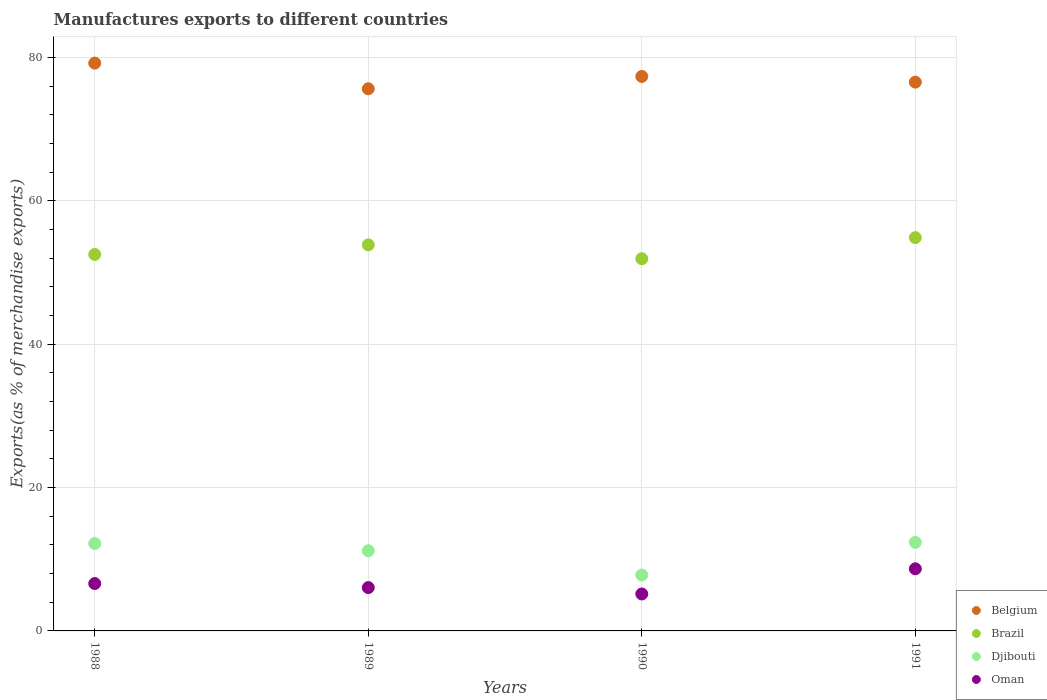How many different coloured dotlines are there?
Give a very brief answer. 4. What is the percentage of exports to different countries in Brazil in 1990?
Provide a succinct answer. 51.92. Across all years, what is the maximum percentage of exports to different countries in Belgium?
Your response must be concise. 79.2. Across all years, what is the minimum percentage of exports to different countries in Djibouti?
Provide a short and direct response. 7.79. In which year was the percentage of exports to different countries in Oman minimum?
Give a very brief answer. 1990. What is the total percentage of exports to different countries in Oman in the graph?
Provide a short and direct response. 26.47. What is the difference between the percentage of exports to different countries in Oman in 1989 and that in 1991?
Offer a very short reply. -2.62. What is the difference between the percentage of exports to different countries in Djibouti in 1991 and the percentage of exports to different countries in Belgium in 1989?
Give a very brief answer. -63.28. What is the average percentage of exports to different countries in Oman per year?
Your response must be concise. 6.62. In the year 1988, what is the difference between the percentage of exports to different countries in Belgium and percentage of exports to different countries in Brazil?
Your answer should be compact. 26.69. What is the ratio of the percentage of exports to different countries in Djibouti in 1990 to that in 1991?
Your answer should be very brief. 0.63. What is the difference between the highest and the second highest percentage of exports to different countries in Brazil?
Your answer should be very brief. 1.01. What is the difference between the highest and the lowest percentage of exports to different countries in Djibouti?
Provide a short and direct response. 4.55. In how many years, is the percentage of exports to different countries in Brazil greater than the average percentage of exports to different countries in Brazil taken over all years?
Ensure brevity in your answer.  2. Is it the case that in every year, the sum of the percentage of exports to different countries in Belgium and percentage of exports to different countries in Djibouti  is greater than the sum of percentage of exports to different countries in Oman and percentage of exports to different countries in Brazil?
Make the answer very short. No. Is it the case that in every year, the sum of the percentage of exports to different countries in Belgium and percentage of exports to different countries in Djibouti  is greater than the percentage of exports to different countries in Brazil?
Your answer should be compact. Yes. Does the percentage of exports to different countries in Belgium monotonically increase over the years?
Offer a very short reply. No. How many dotlines are there?
Your response must be concise. 4. Does the graph contain any zero values?
Ensure brevity in your answer.  No. Does the graph contain grids?
Give a very brief answer. Yes. Where does the legend appear in the graph?
Offer a terse response. Bottom right. What is the title of the graph?
Offer a terse response. Manufactures exports to different countries. Does "Indonesia" appear as one of the legend labels in the graph?
Give a very brief answer. No. What is the label or title of the Y-axis?
Offer a terse response. Exports(as % of merchandise exports). What is the Exports(as % of merchandise exports) in Belgium in 1988?
Provide a succinct answer. 79.2. What is the Exports(as % of merchandise exports) in Brazil in 1988?
Provide a short and direct response. 52.51. What is the Exports(as % of merchandise exports) of Djibouti in 1988?
Your response must be concise. 12.19. What is the Exports(as % of merchandise exports) in Oman in 1988?
Make the answer very short. 6.61. What is the Exports(as % of merchandise exports) of Belgium in 1989?
Your response must be concise. 75.62. What is the Exports(as % of merchandise exports) in Brazil in 1989?
Keep it short and to the point. 53.85. What is the Exports(as % of merchandise exports) of Djibouti in 1989?
Offer a very short reply. 11.19. What is the Exports(as % of merchandise exports) of Oman in 1989?
Ensure brevity in your answer.  6.04. What is the Exports(as % of merchandise exports) of Belgium in 1990?
Give a very brief answer. 77.35. What is the Exports(as % of merchandise exports) of Brazil in 1990?
Provide a short and direct response. 51.92. What is the Exports(as % of merchandise exports) in Djibouti in 1990?
Your answer should be very brief. 7.79. What is the Exports(as % of merchandise exports) of Oman in 1990?
Your answer should be very brief. 5.16. What is the Exports(as % of merchandise exports) of Belgium in 1991?
Your response must be concise. 76.55. What is the Exports(as % of merchandise exports) in Brazil in 1991?
Offer a terse response. 54.86. What is the Exports(as % of merchandise exports) of Djibouti in 1991?
Your answer should be compact. 12.35. What is the Exports(as % of merchandise exports) in Oman in 1991?
Your answer should be very brief. 8.67. Across all years, what is the maximum Exports(as % of merchandise exports) of Belgium?
Keep it short and to the point. 79.2. Across all years, what is the maximum Exports(as % of merchandise exports) of Brazil?
Give a very brief answer. 54.86. Across all years, what is the maximum Exports(as % of merchandise exports) in Djibouti?
Offer a very short reply. 12.35. Across all years, what is the maximum Exports(as % of merchandise exports) of Oman?
Provide a succinct answer. 8.67. Across all years, what is the minimum Exports(as % of merchandise exports) of Belgium?
Keep it short and to the point. 75.62. Across all years, what is the minimum Exports(as % of merchandise exports) of Brazil?
Make the answer very short. 51.92. Across all years, what is the minimum Exports(as % of merchandise exports) of Djibouti?
Your answer should be very brief. 7.79. Across all years, what is the minimum Exports(as % of merchandise exports) of Oman?
Provide a succinct answer. 5.16. What is the total Exports(as % of merchandise exports) of Belgium in the graph?
Ensure brevity in your answer.  308.72. What is the total Exports(as % of merchandise exports) in Brazil in the graph?
Provide a succinct answer. 213.14. What is the total Exports(as % of merchandise exports) of Djibouti in the graph?
Give a very brief answer. 43.52. What is the total Exports(as % of merchandise exports) of Oman in the graph?
Provide a short and direct response. 26.48. What is the difference between the Exports(as % of merchandise exports) in Belgium in 1988 and that in 1989?
Make the answer very short. 3.58. What is the difference between the Exports(as % of merchandise exports) in Brazil in 1988 and that in 1989?
Provide a succinct answer. -1.34. What is the difference between the Exports(as % of merchandise exports) in Oman in 1988 and that in 1989?
Your answer should be compact. 0.56. What is the difference between the Exports(as % of merchandise exports) of Belgium in 1988 and that in 1990?
Your answer should be compact. 1.86. What is the difference between the Exports(as % of merchandise exports) in Brazil in 1988 and that in 1990?
Offer a terse response. 0.6. What is the difference between the Exports(as % of merchandise exports) of Djibouti in 1988 and that in 1990?
Your response must be concise. 4.4. What is the difference between the Exports(as % of merchandise exports) of Oman in 1988 and that in 1990?
Offer a terse response. 1.45. What is the difference between the Exports(as % of merchandise exports) in Belgium in 1988 and that in 1991?
Make the answer very short. 2.65. What is the difference between the Exports(as % of merchandise exports) of Brazil in 1988 and that in 1991?
Provide a succinct answer. -2.35. What is the difference between the Exports(as % of merchandise exports) of Djibouti in 1988 and that in 1991?
Offer a very short reply. -0.16. What is the difference between the Exports(as % of merchandise exports) of Oman in 1988 and that in 1991?
Your answer should be very brief. -2.06. What is the difference between the Exports(as % of merchandise exports) in Belgium in 1989 and that in 1990?
Your response must be concise. -1.72. What is the difference between the Exports(as % of merchandise exports) of Brazil in 1989 and that in 1990?
Give a very brief answer. 1.93. What is the difference between the Exports(as % of merchandise exports) of Djibouti in 1989 and that in 1990?
Ensure brevity in your answer.  3.39. What is the difference between the Exports(as % of merchandise exports) of Oman in 1989 and that in 1990?
Give a very brief answer. 0.89. What is the difference between the Exports(as % of merchandise exports) of Belgium in 1989 and that in 1991?
Provide a succinct answer. -0.93. What is the difference between the Exports(as % of merchandise exports) of Brazil in 1989 and that in 1991?
Provide a succinct answer. -1.01. What is the difference between the Exports(as % of merchandise exports) in Djibouti in 1989 and that in 1991?
Provide a short and direct response. -1.16. What is the difference between the Exports(as % of merchandise exports) of Oman in 1989 and that in 1991?
Keep it short and to the point. -2.62. What is the difference between the Exports(as % of merchandise exports) in Belgium in 1990 and that in 1991?
Ensure brevity in your answer.  0.79. What is the difference between the Exports(as % of merchandise exports) of Brazil in 1990 and that in 1991?
Keep it short and to the point. -2.95. What is the difference between the Exports(as % of merchandise exports) of Djibouti in 1990 and that in 1991?
Keep it short and to the point. -4.55. What is the difference between the Exports(as % of merchandise exports) in Oman in 1990 and that in 1991?
Give a very brief answer. -3.51. What is the difference between the Exports(as % of merchandise exports) of Belgium in 1988 and the Exports(as % of merchandise exports) of Brazil in 1989?
Your response must be concise. 25.35. What is the difference between the Exports(as % of merchandise exports) of Belgium in 1988 and the Exports(as % of merchandise exports) of Djibouti in 1989?
Keep it short and to the point. 68.02. What is the difference between the Exports(as % of merchandise exports) in Belgium in 1988 and the Exports(as % of merchandise exports) in Oman in 1989?
Ensure brevity in your answer.  73.16. What is the difference between the Exports(as % of merchandise exports) of Brazil in 1988 and the Exports(as % of merchandise exports) of Djibouti in 1989?
Your response must be concise. 41.33. What is the difference between the Exports(as % of merchandise exports) of Brazil in 1988 and the Exports(as % of merchandise exports) of Oman in 1989?
Provide a succinct answer. 46.47. What is the difference between the Exports(as % of merchandise exports) in Djibouti in 1988 and the Exports(as % of merchandise exports) in Oman in 1989?
Offer a very short reply. 6.15. What is the difference between the Exports(as % of merchandise exports) in Belgium in 1988 and the Exports(as % of merchandise exports) in Brazil in 1990?
Your answer should be very brief. 27.29. What is the difference between the Exports(as % of merchandise exports) of Belgium in 1988 and the Exports(as % of merchandise exports) of Djibouti in 1990?
Provide a short and direct response. 71.41. What is the difference between the Exports(as % of merchandise exports) of Belgium in 1988 and the Exports(as % of merchandise exports) of Oman in 1990?
Make the answer very short. 74.05. What is the difference between the Exports(as % of merchandise exports) in Brazil in 1988 and the Exports(as % of merchandise exports) in Djibouti in 1990?
Your answer should be compact. 44.72. What is the difference between the Exports(as % of merchandise exports) in Brazil in 1988 and the Exports(as % of merchandise exports) in Oman in 1990?
Ensure brevity in your answer.  47.36. What is the difference between the Exports(as % of merchandise exports) in Djibouti in 1988 and the Exports(as % of merchandise exports) in Oman in 1990?
Give a very brief answer. 7.04. What is the difference between the Exports(as % of merchandise exports) of Belgium in 1988 and the Exports(as % of merchandise exports) of Brazil in 1991?
Offer a terse response. 24.34. What is the difference between the Exports(as % of merchandise exports) of Belgium in 1988 and the Exports(as % of merchandise exports) of Djibouti in 1991?
Ensure brevity in your answer.  66.86. What is the difference between the Exports(as % of merchandise exports) of Belgium in 1988 and the Exports(as % of merchandise exports) of Oman in 1991?
Your answer should be compact. 70.54. What is the difference between the Exports(as % of merchandise exports) of Brazil in 1988 and the Exports(as % of merchandise exports) of Djibouti in 1991?
Make the answer very short. 40.17. What is the difference between the Exports(as % of merchandise exports) in Brazil in 1988 and the Exports(as % of merchandise exports) in Oman in 1991?
Ensure brevity in your answer.  43.85. What is the difference between the Exports(as % of merchandise exports) in Djibouti in 1988 and the Exports(as % of merchandise exports) in Oman in 1991?
Provide a succinct answer. 3.53. What is the difference between the Exports(as % of merchandise exports) in Belgium in 1989 and the Exports(as % of merchandise exports) in Brazil in 1990?
Ensure brevity in your answer.  23.71. What is the difference between the Exports(as % of merchandise exports) in Belgium in 1989 and the Exports(as % of merchandise exports) in Djibouti in 1990?
Your response must be concise. 67.83. What is the difference between the Exports(as % of merchandise exports) in Belgium in 1989 and the Exports(as % of merchandise exports) in Oman in 1990?
Provide a short and direct response. 70.47. What is the difference between the Exports(as % of merchandise exports) in Brazil in 1989 and the Exports(as % of merchandise exports) in Djibouti in 1990?
Your answer should be very brief. 46.06. What is the difference between the Exports(as % of merchandise exports) of Brazil in 1989 and the Exports(as % of merchandise exports) of Oman in 1990?
Make the answer very short. 48.7. What is the difference between the Exports(as % of merchandise exports) in Djibouti in 1989 and the Exports(as % of merchandise exports) in Oman in 1990?
Provide a succinct answer. 6.03. What is the difference between the Exports(as % of merchandise exports) of Belgium in 1989 and the Exports(as % of merchandise exports) of Brazil in 1991?
Offer a terse response. 20.76. What is the difference between the Exports(as % of merchandise exports) of Belgium in 1989 and the Exports(as % of merchandise exports) of Djibouti in 1991?
Your answer should be compact. 63.28. What is the difference between the Exports(as % of merchandise exports) of Belgium in 1989 and the Exports(as % of merchandise exports) of Oman in 1991?
Ensure brevity in your answer.  66.96. What is the difference between the Exports(as % of merchandise exports) of Brazil in 1989 and the Exports(as % of merchandise exports) of Djibouti in 1991?
Provide a succinct answer. 41.5. What is the difference between the Exports(as % of merchandise exports) in Brazil in 1989 and the Exports(as % of merchandise exports) in Oman in 1991?
Offer a very short reply. 45.18. What is the difference between the Exports(as % of merchandise exports) in Djibouti in 1989 and the Exports(as % of merchandise exports) in Oman in 1991?
Your response must be concise. 2.52. What is the difference between the Exports(as % of merchandise exports) of Belgium in 1990 and the Exports(as % of merchandise exports) of Brazil in 1991?
Provide a short and direct response. 22.48. What is the difference between the Exports(as % of merchandise exports) in Belgium in 1990 and the Exports(as % of merchandise exports) in Djibouti in 1991?
Make the answer very short. 65. What is the difference between the Exports(as % of merchandise exports) of Belgium in 1990 and the Exports(as % of merchandise exports) of Oman in 1991?
Offer a terse response. 68.68. What is the difference between the Exports(as % of merchandise exports) in Brazil in 1990 and the Exports(as % of merchandise exports) in Djibouti in 1991?
Your answer should be very brief. 39.57. What is the difference between the Exports(as % of merchandise exports) in Brazil in 1990 and the Exports(as % of merchandise exports) in Oman in 1991?
Make the answer very short. 43.25. What is the difference between the Exports(as % of merchandise exports) in Djibouti in 1990 and the Exports(as % of merchandise exports) in Oman in 1991?
Provide a short and direct response. -0.87. What is the average Exports(as % of merchandise exports) in Belgium per year?
Give a very brief answer. 77.18. What is the average Exports(as % of merchandise exports) in Brazil per year?
Ensure brevity in your answer.  53.29. What is the average Exports(as % of merchandise exports) in Djibouti per year?
Provide a succinct answer. 10.88. What is the average Exports(as % of merchandise exports) of Oman per year?
Ensure brevity in your answer.  6.62. In the year 1988, what is the difference between the Exports(as % of merchandise exports) of Belgium and Exports(as % of merchandise exports) of Brazil?
Offer a very short reply. 26.69. In the year 1988, what is the difference between the Exports(as % of merchandise exports) in Belgium and Exports(as % of merchandise exports) in Djibouti?
Your response must be concise. 67.01. In the year 1988, what is the difference between the Exports(as % of merchandise exports) of Belgium and Exports(as % of merchandise exports) of Oman?
Give a very brief answer. 72.6. In the year 1988, what is the difference between the Exports(as % of merchandise exports) of Brazil and Exports(as % of merchandise exports) of Djibouti?
Give a very brief answer. 40.32. In the year 1988, what is the difference between the Exports(as % of merchandise exports) in Brazil and Exports(as % of merchandise exports) in Oman?
Provide a short and direct response. 45.91. In the year 1988, what is the difference between the Exports(as % of merchandise exports) in Djibouti and Exports(as % of merchandise exports) in Oman?
Ensure brevity in your answer.  5.58. In the year 1989, what is the difference between the Exports(as % of merchandise exports) in Belgium and Exports(as % of merchandise exports) in Brazil?
Keep it short and to the point. 21.77. In the year 1989, what is the difference between the Exports(as % of merchandise exports) of Belgium and Exports(as % of merchandise exports) of Djibouti?
Provide a short and direct response. 64.44. In the year 1989, what is the difference between the Exports(as % of merchandise exports) of Belgium and Exports(as % of merchandise exports) of Oman?
Offer a very short reply. 69.58. In the year 1989, what is the difference between the Exports(as % of merchandise exports) of Brazil and Exports(as % of merchandise exports) of Djibouti?
Your answer should be compact. 42.66. In the year 1989, what is the difference between the Exports(as % of merchandise exports) in Brazil and Exports(as % of merchandise exports) in Oman?
Offer a very short reply. 47.81. In the year 1989, what is the difference between the Exports(as % of merchandise exports) in Djibouti and Exports(as % of merchandise exports) in Oman?
Provide a short and direct response. 5.14. In the year 1990, what is the difference between the Exports(as % of merchandise exports) of Belgium and Exports(as % of merchandise exports) of Brazil?
Offer a terse response. 25.43. In the year 1990, what is the difference between the Exports(as % of merchandise exports) of Belgium and Exports(as % of merchandise exports) of Djibouti?
Your answer should be compact. 69.55. In the year 1990, what is the difference between the Exports(as % of merchandise exports) in Belgium and Exports(as % of merchandise exports) in Oman?
Offer a terse response. 72.19. In the year 1990, what is the difference between the Exports(as % of merchandise exports) in Brazil and Exports(as % of merchandise exports) in Djibouti?
Your answer should be compact. 44.12. In the year 1990, what is the difference between the Exports(as % of merchandise exports) in Brazil and Exports(as % of merchandise exports) in Oman?
Your response must be concise. 46.76. In the year 1990, what is the difference between the Exports(as % of merchandise exports) in Djibouti and Exports(as % of merchandise exports) in Oman?
Your answer should be compact. 2.64. In the year 1991, what is the difference between the Exports(as % of merchandise exports) in Belgium and Exports(as % of merchandise exports) in Brazil?
Make the answer very short. 21.69. In the year 1991, what is the difference between the Exports(as % of merchandise exports) in Belgium and Exports(as % of merchandise exports) in Djibouti?
Provide a succinct answer. 64.2. In the year 1991, what is the difference between the Exports(as % of merchandise exports) of Belgium and Exports(as % of merchandise exports) of Oman?
Offer a very short reply. 67.89. In the year 1991, what is the difference between the Exports(as % of merchandise exports) of Brazil and Exports(as % of merchandise exports) of Djibouti?
Offer a very short reply. 42.51. In the year 1991, what is the difference between the Exports(as % of merchandise exports) in Brazil and Exports(as % of merchandise exports) in Oman?
Make the answer very short. 46.2. In the year 1991, what is the difference between the Exports(as % of merchandise exports) in Djibouti and Exports(as % of merchandise exports) in Oman?
Keep it short and to the point. 3.68. What is the ratio of the Exports(as % of merchandise exports) of Belgium in 1988 to that in 1989?
Ensure brevity in your answer.  1.05. What is the ratio of the Exports(as % of merchandise exports) of Brazil in 1988 to that in 1989?
Your answer should be very brief. 0.98. What is the ratio of the Exports(as % of merchandise exports) in Djibouti in 1988 to that in 1989?
Your response must be concise. 1.09. What is the ratio of the Exports(as % of merchandise exports) in Oman in 1988 to that in 1989?
Provide a short and direct response. 1.09. What is the ratio of the Exports(as % of merchandise exports) in Belgium in 1988 to that in 1990?
Ensure brevity in your answer.  1.02. What is the ratio of the Exports(as % of merchandise exports) of Brazil in 1988 to that in 1990?
Your response must be concise. 1.01. What is the ratio of the Exports(as % of merchandise exports) of Djibouti in 1988 to that in 1990?
Ensure brevity in your answer.  1.56. What is the ratio of the Exports(as % of merchandise exports) in Oman in 1988 to that in 1990?
Offer a terse response. 1.28. What is the ratio of the Exports(as % of merchandise exports) in Belgium in 1988 to that in 1991?
Your response must be concise. 1.03. What is the ratio of the Exports(as % of merchandise exports) in Brazil in 1988 to that in 1991?
Your answer should be very brief. 0.96. What is the ratio of the Exports(as % of merchandise exports) in Djibouti in 1988 to that in 1991?
Offer a very short reply. 0.99. What is the ratio of the Exports(as % of merchandise exports) of Oman in 1988 to that in 1991?
Give a very brief answer. 0.76. What is the ratio of the Exports(as % of merchandise exports) in Belgium in 1989 to that in 1990?
Your answer should be compact. 0.98. What is the ratio of the Exports(as % of merchandise exports) in Brazil in 1989 to that in 1990?
Your answer should be compact. 1.04. What is the ratio of the Exports(as % of merchandise exports) of Djibouti in 1989 to that in 1990?
Make the answer very short. 1.44. What is the ratio of the Exports(as % of merchandise exports) of Oman in 1989 to that in 1990?
Keep it short and to the point. 1.17. What is the ratio of the Exports(as % of merchandise exports) of Belgium in 1989 to that in 1991?
Give a very brief answer. 0.99. What is the ratio of the Exports(as % of merchandise exports) of Brazil in 1989 to that in 1991?
Ensure brevity in your answer.  0.98. What is the ratio of the Exports(as % of merchandise exports) in Djibouti in 1989 to that in 1991?
Give a very brief answer. 0.91. What is the ratio of the Exports(as % of merchandise exports) in Oman in 1989 to that in 1991?
Offer a very short reply. 0.7. What is the ratio of the Exports(as % of merchandise exports) of Belgium in 1990 to that in 1991?
Provide a short and direct response. 1.01. What is the ratio of the Exports(as % of merchandise exports) in Brazil in 1990 to that in 1991?
Make the answer very short. 0.95. What is the ratio of the Exports(as % of merchandise exports) of Djibouti in 1990 to that in 1991?
Ensure brevity in your answer.  0.63. What is the ratio of the Exports(as % of merchandise exports) in Oman in 1990 to that in 1991?
Make the answer very short. 0.59. What is the difference between the highest and the second highest Exports(as % of merchandise exports) of Belgium?
Offer a very short reply. 1.86. What is the difference between the highest and the second highest Exports(as % of merchandise exports) of Brazil?
Offer a very short reply. 1.01. What is the difference between the highest and the second highest Exports(as % of merchandise exports) of Djibouti?
Your response must be concise. 0.16. What is the difference between the highest and the second highest Exports(as % of merchandise exports) in Oman?
Provide a short and direct response. 2.06. What is the difference between the highest and the lowest Exports(as % of merchandise exports) of Belgium?
Provide a short and direct response. 3.58. What is the difference between the highest and the lowest Exports(as % of merchandise exports) of Brazil?
Provide a succinct answer. 2.95. What is the difference between the highest and the lowest Exports(as % of merchandise exports) in Djibouti?
Your response must be concise. 4.55. What is the difference between the highest and the lowest Exports(as % of merchandise exports) in Oman?
Keep it short and to the point. 3.51. 